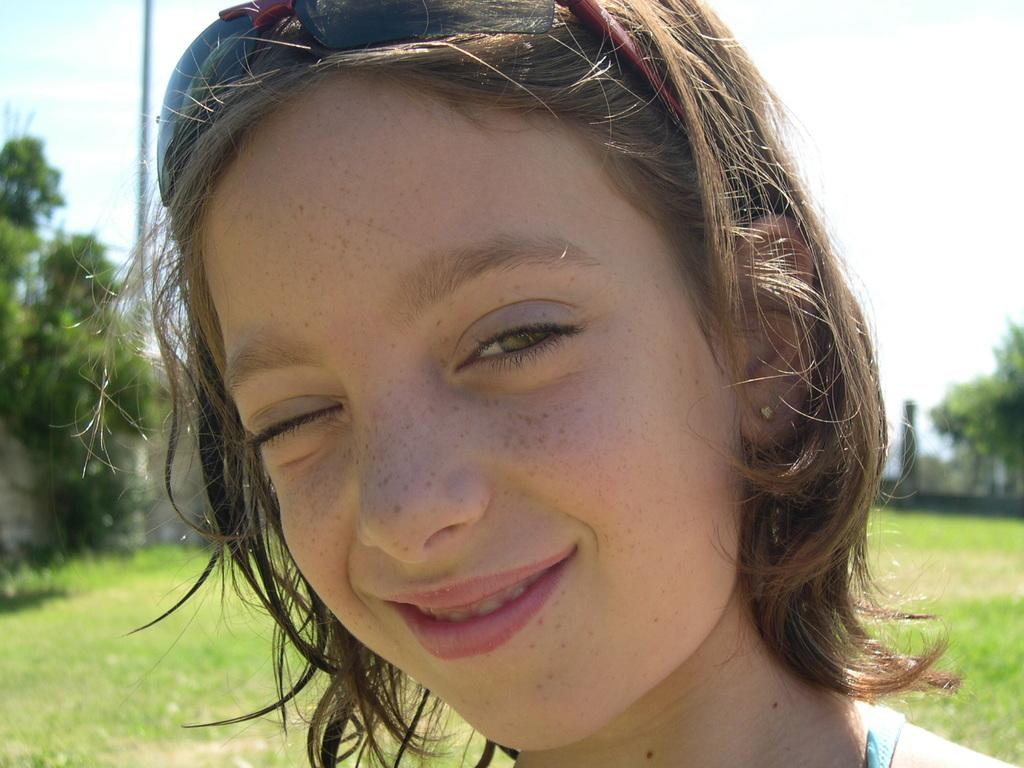Who is the main subject in the foreground of the image? There is a woman in the foreground of the image. What can be seen in the background of the image? There are trees and a wall in the background of the image. What type of ground surface is visible at the bottom of the image? There is grass visible at the bottom of the image. What type of notebook is being used by the woman in the image? There is no notebook present in the image; the woman is the only subject visible. 